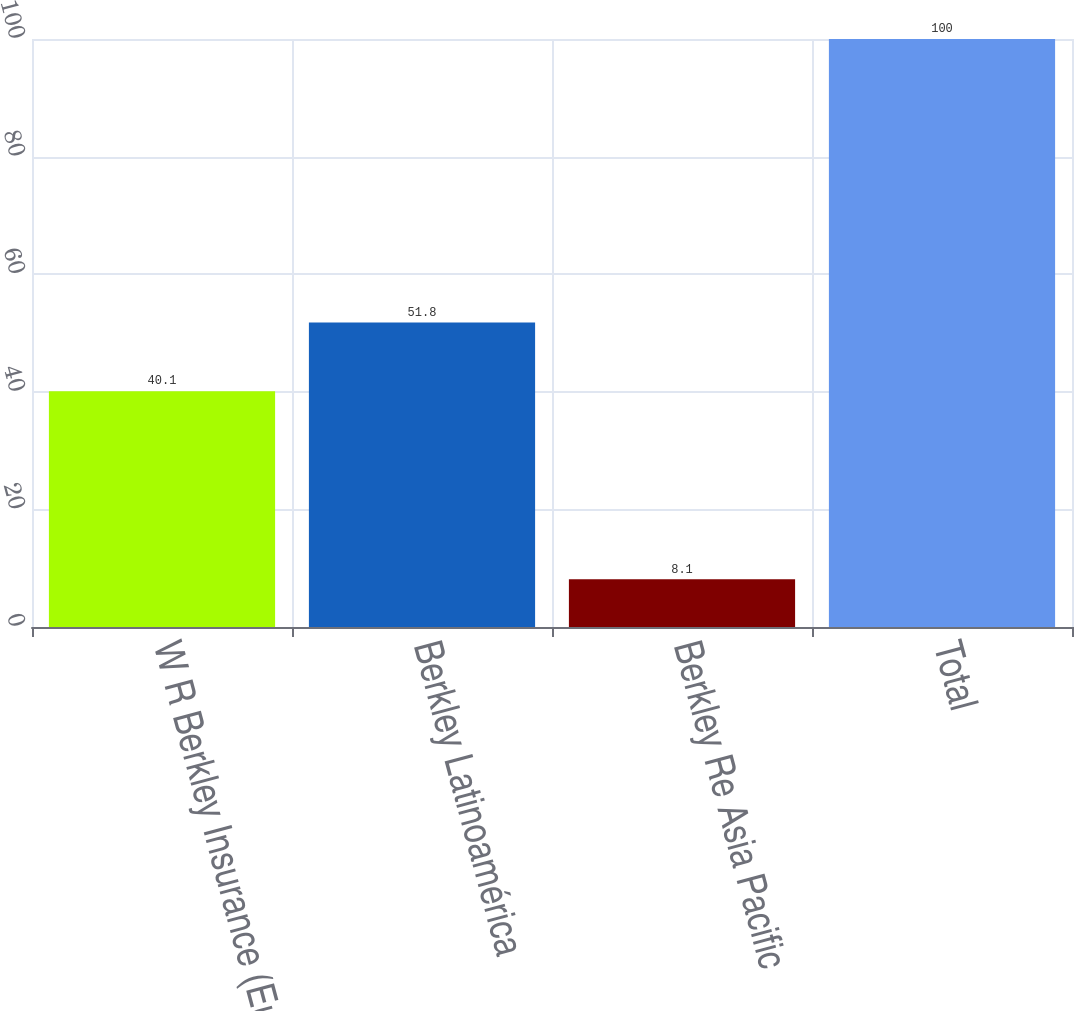Convert chart. <chart><loc_0><loc_0><loc_500><loc_500><bar_chart><fcel>W R Berkley Insurance (Europe)<fcel>Berkley Latinoamérica<fcel>Berkley Re Asia Pacific<fcel>Total<nl><fcel>40.1<fcel>51.8<fcel>8.1<fcel>100<nl></chart> 